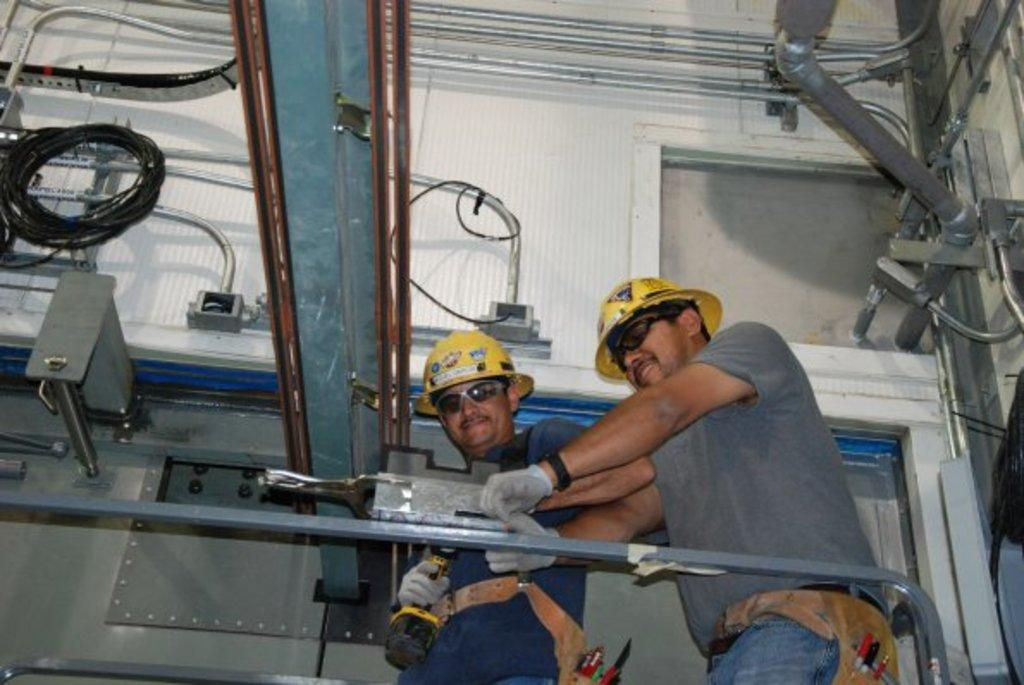How many people are in the image? There are two people in the image. What protective gear are the people wearing? The people are wearing helmets, goggles, and gloves. What objects can be seen in the image related to construction or maintenance? There are rods, pipes, wire, and tools in the image. What type of background is visible in the image? There is a wall in the image. Are there any unidentified objects in the image? Yes, there are some unspecified objects in the image. Can you see any waves in the image? There are no waves visible in the image. What type of fruit is being used as a skate by one of the people in the image? There is no fruit, such as a banana, being used as a skate in the image. 